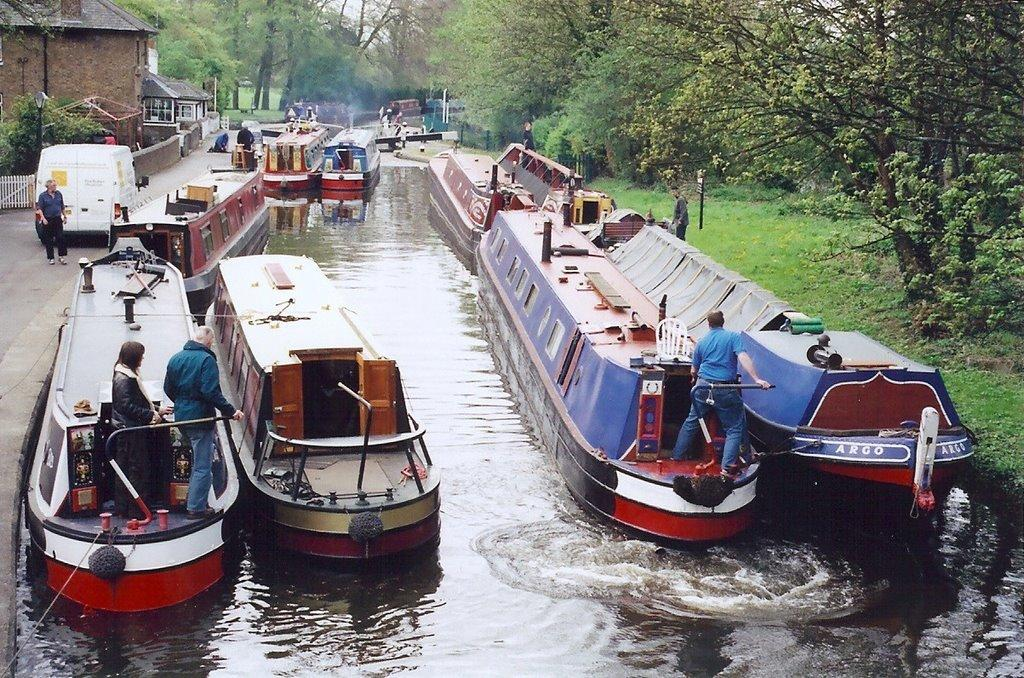What is on the water in the image? There are boats on the water in the image. What type of natural environment can be seen in the image? There are trees visible in the image. What type of structure is present in the image? There is a building in the image. How many people are visible in the image? There are people (few persons) in the image. What mode of transportation is present in the image? There is a vehicle in the image. What type of zephyr can be seen blowing through the trees in the image? There is no mention of a zephyr in the image, and it is not possible to determine the presence or type of wind from the image alone. What message of hope can be read from the building in the image? There is no message or text visible on the building in the image, so it is not possible to determine any message of hope. 